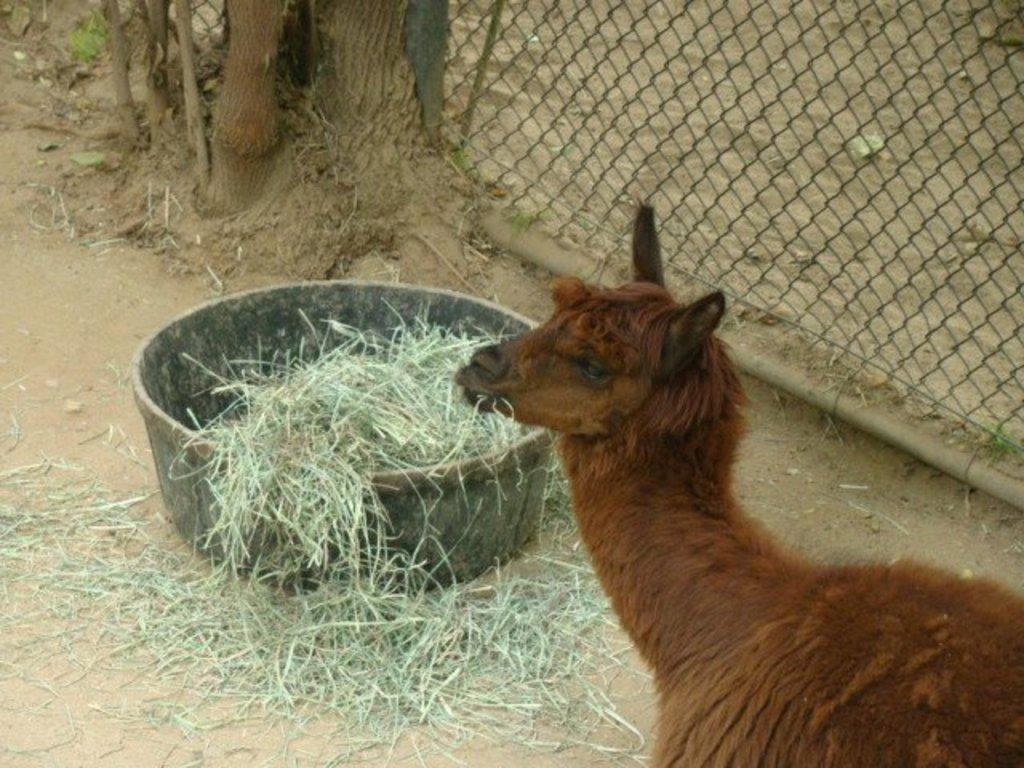What type of animal can be seen in the image? There is an animal in the image, but its specific type is not mentioned in the facts. What is the animal doing in the image? The animal is grazing grass in the image. How is the grass contained in the image? The grass is kept in a bowl in the image. What can be seen on the right side of the image? There is a mesh on the right side of the image. What is located in front of the mesh? There is a tree in front of the mesh in the image. Can you see the rod in the image? There is no mention of a rod in the image. 